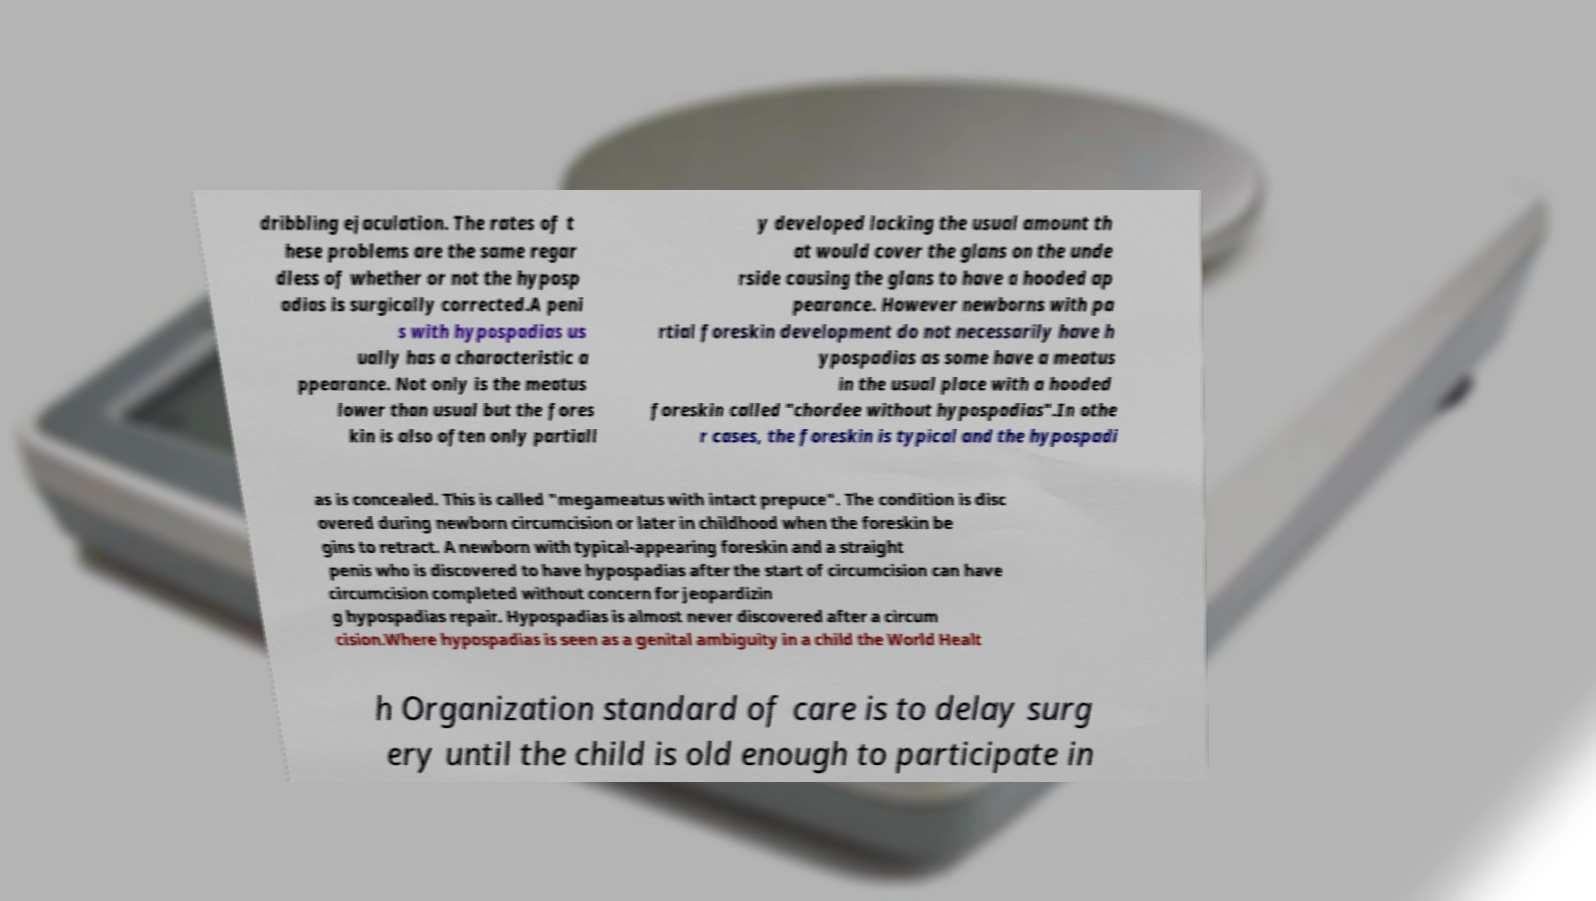Can you accurately transcribe the text from the provided image for me? dribbling ejaculation. The rates of t hese problems are the same regar dless of whether or not the hyposp adias is surgically corrected.A peni s with hypospadias us ually has a characteristic a ppearance. Not only is the meatus lower than usual but the fores kin is also often only partiall y developed lacking the usual amount th at would cover the glans on the unde rside causing the glans to have a hooded ap pearance. However newborns with pa rtial foreskin development do not necessarily have h ypospadias as some have a meatus in the usual place with a hooded foreskin called "chordee without hypospadias".In othe r cases, the foreskin is typical and the hypospadi as is concealed. This is called "megameatus with intact prepuce". The condition is disc overed during newborn circumcision or later in childhood when the foreskin be gins to retract. A newborn with typical-appearing foreskin and a straight penis who is discovered to have hypospadias after the start of circumcision can have circumcision completed without concern for jeopardizin g hypospadias repair. Hypospadias is almost never discovered after a circum cision.Where hypospadias is seen as a genital ambiguity in a child the World Healt h Organization standard of care is to delay surg ery until the child is old enough to participate in 